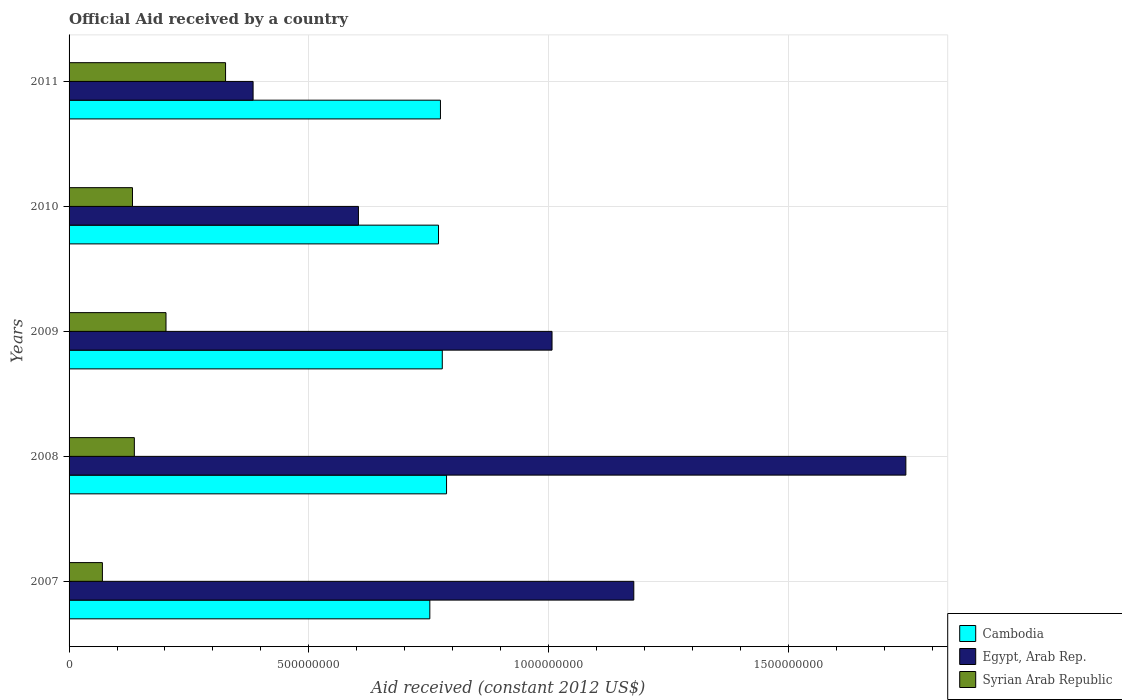How many groups of bars are there?
Ensure brevity in your answer.  5. Are the number of bars on each tick of the Y-axis equal?
Provide a short and direct response. Yes. How many bars are there on the 5th tick from the bottom?
Provide a short and direct response. 3. In how many cases, is the number of bars for a given year not equal to the number of legend labels?
Give a very brief answer. 0. What is the net official aid received in Syrian Arab Republic in 2007?
Your answer should be very brief. 6.95e+07. Across all years, what is the maximum net official aid received in Cambodia?
Provide a succinct answer. 7.87e+08. Across all years, what is the minimum net official aid received in Syrian Arab Republic?
Give a very brief answer. 6.95e+07. In which year was the net official aid received in Syrian Arab Republic minimum?
Your answer should be compact. 2007. What is the total net official aid received in Cambodia in the graph?
Your answer should be compact. 3.86e+09. What is the difference between the net official aid received in Cambodia in 2007 and that in 2009?
Your response must be concise. -2.60e+07. What is the difference between the net official aid received in Syrian Arab Republic in 2009 and the net official aid received in Cambodia in 2011?
Provide a short and direct response. -5.72e+08. What is the average net official aid received in Egypt, Arab Rep. per year?
Ensure brevity in your answer.  9.84e+08. In the year 2009, what is the difference between the net official aid received in Egypt, Arab Rep. and net official aid received in Syrian Arab Republic?
Your answer should be compact. 8.05e+08. In how many years, is the net official aid received in Syrian Arab Republic greater than 900000000 US$?
Make the answer very short. 0. What is the ratio of the net official aid received in Egypt, Arab Rep. in 2008 to that in 2010?
Offer a terse response. 2.89. Is the net official aid received in Cambodia in 2007 less than that in 2009?
Keep it short and to the point. Yes. Is the difference between the net official aid received in Egypt, Arab Rep. in 2008 and 2010 greater than the difference between the net official aid received in Syrian Arab Republic in 2008 and 2010?
Your response must be concise. Yes. What is the difference between the highest and the second highest net official aid received in Syrian Arab Republic?
Ensure brevity in your answer.  1.24e+08. What is the difference between the highest and the lowest net official aid received in Cambodia?
Provide a succinct answer. 3.49e+07. In how many years, is the net official aid received in Egypt, Arab Rep. greater than the average net official aid received in Egypt, Arab Rep. taken over all years?
Your answer should be very brief. 3. What does the 1st bar from the top in 2010 represents?
Offer a terse response. Syrian Arab Republic. What does the 1st bar from the bottom in 2009 represents?
Your answer should be very brief. Cambodia. Is it the case that in every year, the sum of the net official aid received in Cambodia and net official aid received in Egypt, Arab Rep. is greater than the net official aid received in Syrian Arab Republic?
Your response must be concise. Yes. How many years are there in the graph?
Offer a very short reply. 5. What is the difference between two consecutive major ticks on the X-axis?
Your response must be concise. 5.00e+08. Does the graph contain grids?
Ensure brevity in your answer.  Yes. Where does the legend appear in the graph?
Ensure brevity in your answer.  Bottom right. How many legend labels are there?
Your answer should be very brief. 3. What is the title of the graph?
Provide a short and direct response. Official Aid received by a country. Does "Lao PDR" appear as one of the legend labels in the graph?
Offer a terse response. No. What is the label or title of the X-axis?
Make the answer very short. Aid received (constant 2012 US$). What is the Aid received (constant 2012 US$) in Cambodia in 2007?
Give a very brief answer. 7.52e+08. What is the Aid received (constant 2012 US$) of Egypt, Arab Rep. in 2007?
Your answer should be compact. 1.18e+09. What is the Aid received (constant 2012 US$) of Syrian Arab Republic in 2007?
Your answer should be compact. 6.95e+07. What is the Aid received (constant 2012 US$) in Cambodia in 2008?
Ensure brevity in your answer.  7.87e+08. What is the Aid received (constant 2012 US$) of Egypt, Arab Rep. in 2008?
Give a very brief answer. 1.75e+09. What is the Aid received (constant 2012 US$) in Syrian Arab Republic in 2008?
Provide a succinct answer. 1.36e+08. What is the Aid received (constant 2012 US$) of Cambodia in 2009?
Provide a succinct answer. 7.78e+08. What is the Aid received (constant 2012 US$) in Egypt, Arab Rep. in 2009?
Give a very brief answer. 1.01e+09. What is the Aid received (constant 2012 US$) in Syrian Arab Republic in 2009?
Provide a succinct answer. 2.02e+08. What is the Aid received (constant 2012 US$) of Cambodia in 2010?
Give a very brief answer. 7.71e+08. What is the Aid received (constant 2012 US$) of Egypt, Arab Rep. in 2010?
Provide a succinct answer. 6.04e+08. What is the Aid received (constant 2012 US$) of Syrian Arab Republic in 2010?
Provide a short and direct response. 1.32e+08. What is the Aid received (constant 2012 US$) in Cambodia in 2011?
Provide a short and direct response. 7.75e+08. What is the Aid received (constant 2012 US$) of Egypt, Arab Rep. in 2011?
Make the answer very short. 3.84e+08. What is the Aid received (constant 2012 US$) in Syrian Arab Republic in 2011?
Offer a terse response. 3.26e+08. Across all years, what is the maximum Aid received (constant 2012 US$) in Cambodia?
Ensure brevity in your answer.  7.87e+08. Across all years, what is the maximum Aid received (constant 2012 US$) of Egypt, Arab Rep.?
Keep it short and to the point. 1.75e+09. Across all years, what is the maximum Aid received (constant 2012 US$) of Syrian Arab Republic?
Keep it short and to the point. 3.26e+08. Across all years, what is the minimum Aid received (constant 2012 US$) of Cambodia?
Your answer should be very brief. 7.52e+08. Across all years, what is the minimum Aid received (constant 2012 US$) of Egypt, Arab Rep.?
Your answer should be very brief. 3.84e+08. Across all years, what is the minimum Aid received (constant 2012 US$) of Syrian Arab Republic?
Your response must be concise. 6.95e+07. What is the total Aid received (constant 2012 US$) in Cambodia in the graph?
Your answer should be very brief. 3.86e+09. What is the total Aid received (constant 2012 US$) in Egypt, Arab Rep. in the graph?
Keep it short and to the point. 4.92e+09. What is the total Aid received (constant 2012 US$) in Syrian Arab Republic in the graph?
Ensure brevity in your answer.  8.66e+08. What is the difference between the Aid received (constant 2012 US$) in Cambodia in 2007 and that in 2008?
Make the answer very short. -3.49e+07. What is the difference between the Aid received (constant 2012 US$) of Egypt, Arab Rep. in 2007 and that in 2008?
Ensure brevity in your answer.  -5.67e+08. What is the difference between the Aid received (constant 2012 US$) in Syrian Arab Republic in 2007 and that in 2008?
Make the answer very short. -6.66e+07. What is the difference between the Aid received (constant 2012 US$) in Cambodia in 2007 and that in 2009?
Keep it short and to the point. -2.60e+07. What is the difference between the Aid received (constant 2012 US$) in Egypt, Arab Rep. in 2007 and that in 2009?
Provide a short and direct response. 1.71e+08. What is the difference between the Aid received (constant 2012 US$) of Syrian Arab Republic in 2007 and that in 2009?
Provide a short and direct response. -1.33e+08. What is the difference between the Aid received (constant 2012 US$) in Cambodia in 2007 and that in 2010?
Your answer should be compact. -1.81e+07. What is the difference between the Aid received (constant 2012 US$) of Egypt, Arab Rep. in 2007 and that in 2010?
Your answer should be compact. 5.74e+08. What is the difference between the Aid received (constant 2012 US$) of Syrian Arab Republic in 2007 and that in 2010?
Your answer should be compact. -6.27e+07. What is the difference between the Aid received (constant 2012 US$) of Cambodia in 2007 and that in 2011?
Give a very brief answer. -2.22e+07. What is the difference between the Aid received (constant 2012 US$) of Egypt, Arab Rep. in 2007 and that in 2011?
Offer a terse response. 7.94e+08. What is the difference between the Aid received (constant 2012 US$) in Syrian Arab Republic in 2007 and that in 2011?
Make the answer very short. -2.57e+08. What is the difference between the Aid received (constant 2012 US$) in Cambodia in 2008 and that in 2009?
Keep it short and to the point. 8.88e+06. What is the difference between the Aid received (constant 2012 US$) in Egypt, Arab Rep. in 2008 and that in 2009?
Provide a succinct answer. 7.38e+08. What is the difference between the Aid received (constant 2012 US$) in Syrian Arab Republic in 2008 and that in 2009?
Your response must be concise. -6.60e+07. What is the difference between the Aid received (constant 2012 US$) in Cambodia in 2008 and that in 2010?
Your answer should be compact. 1.68e+07. What is the difference between the Aid received (constant 2012 US$) of Egypt, Arab Rep. in 2008 and that in 2010?
Offer a terse response. 1.14e+09. What is the difference between the Aid received (constant 2012 US$) in Syrian Arab Republic in 2008 and that in 2010?
Offer a terse response. 3.90e+06. What is the difference between the Aid received (constant 2012 US$) of Cambodia in 2008 and that in 2011?
Your answer should be very brief. 1.27e+07. What is the difference between the Aid received (constant 2012 US$) in Egypt, Arab Rep. in 2008 and that in 2011?
Make the answer very short. 1.36e+09. What is the difference between the Aid received (constant 2012 US$) in Syrian Arab Republic in 2008 and that in 2011?
Offer a terse response. -1.90e+08. What is the difference between the Aid received (constant 2012 US$) in Cambodia in 2009 and that in 2010?
Your answer should be compact. 7.87e+06. What is the difference between the Aid received (constant 2012 US$) of Egypt, Arab Rep. in 2009 and that in 2010?
Keep it short and to the point. 4.04e+08. What is the difference between the Aid received (constant 2012 US$) of Syrian Arab Republic in 2009 and that in 2010?
Provide a short and direct response. 6.99e+07. What is the difference between the Aid received (constant 2012 US$) of Cambodia in 2009 and that in 2011?
Ensure brevity in your answer.  3.82e+06. What is the difference between the Aid received (constant 2012 US$) of Egypt, Arab Rep. in 2009 and that in 2011?
Offer a terse response. 6.24e+08. What is the difference between the Aid received (constant 2012 US$) in Syrian Arab Republic in 2009 and that in 2011?
Make the answer very short. -1.24e+08. What is the difference between the Aid received (constant 2012 US$) of Cambodia in 2010 and that in 2011?
Ensure brevity in your answer.  -4.05e+06. What is the difference between the Aid received (constant 2012 US$) of Egypt, Arab Rep. in 2010 and that in 2011?
Offer a very short reply. 2.20e+08. What is the difference between the Aid received (constant 2012 US$) in Syrian Arab Republic in 2010 and that in 2011?
Your response must be concise. -1.94e+08. What is the difference between the Aid received (constant 2012 US$) of Cambodia in 2007 and the Aid received (constant 2012 US$) of Egypt, Arab Rep. in 2008?
Your answer should be very brief. -9.93e+08. What is the difference between the Aid received (constant 2012 US$) in Cambodia in 2007 and the Aid received (constant 2012 US$) in Syrian Arab Republic in 2008?
Provide a short and direct response. 6.16e+08. What is the difference between the Aid received (constant 2012 US$) of Egypt, Arab Rep. in 2007 and the Aid received (constant 2012 US$) of Syrian Arab Republic in 2008?
Offer a terse response. 1.04e+09. What is the difference between the Aid received (constant 2012 US$) in Cambodia in 2007 and the Aid received (constant 2012 US$) in Egypt, Arab Rep. in 2009?
Provide a short and direct response. -2.55e+08. What is the difference between the Aid received (constant 2012 US$) in Cambodia in 2007 and the Aid received (constant 2012 US$) in Syrian Arab Republic in 2009?
Make the answer very short. 5.50e+08. What is the difference between the Aid received (constant 2012 US$) of Egypt, Arab Rep. in 2007 and the Aid received (constant 2012 US$) of Syrian Arab Republic in 2009?
Provide a short and direct response. 9.76e+08. What is the difference between the Aid received (constant 2012 US$) in Cambodia in 2007 and the Aid received (constant 2012 US$) in Egypt, Arab Rep. in 2010?
Your answer should be compact. 1.49e+08. What is the difference between the Aid received (constant 2012 US$) in Cambodia in 2007 and the Aid received (constant 2012 US$) in Syrian Arab Republic in 2010?
Offer a very short reply. 6.20e+08. What is the difference between the Aid received (constant 2012 US$) in Egypt, Arab Rep. in 2007 and the Aid received (constant 2012 US$) in Syrian Arab Republic in 2010?
Your answer should be compact. 1.05e+09. What is the difference between the Aid received (constant 2012 US$) in Cambodia in 2007 and the Aid received (constant 2012 US$) in Egypt, Arab Rep. in 2011?
Provide a succinct answer. 3.69e+08. What is the difference between the Aid received (constant 2012 US$) in Cambodia in 2007 and the Aid received (constant 2012 US$) in Syrian Arab Republic in 2011?
Offer a terse response. 4.26e+08. What is the difference between the Aid received (constant 2012 US$) of Egypt, Arab Rep. in 2007 and the Aid received (constant 2012 US$) of Syrian Arab Republic in 2011?
Provide a succinct answer. 8.51e+08. What is the difference between the Aid received (constant 2012 US$) in Cambodia in 2008 and the Aid received (constant 2012 US$) in Egypt, Arab Rep. in 2009?
Provide a succinct answer. -2.20e+08. What is the difference between the Aid received (constant 2012 US$) in Cambodia in 2008 and the Aid received (constant 2012 US$) in Syrian Arab Republic in 2009?
Offer a terse response. 5.85e+08. What is the difference between the Aid received (constant 2012 US$) of Egypt, Arab Rep. in 2008 and the Aid received (constant 2012 US$) of Syrian Arab Republic in 2009?
Your answer should be compact. 1.54e+09. What is the difference between the Aid received (constant 2012 US$) of Cambodia in 2008 and the Aid received (constant 2012 US$) of Egypt, Arab Rep. in 2010?
Provide a succinct answer. 1.84e+08. What is the difference between the Aid received (constant 2012 US$) in Cambodia in 2008 and the Aid received (constant 2012 US$) in Syrian Arab Republic in 2010?
Your answer should be very brief. 6.55e+08. What is the difference between the Aid received (constant 2012 US$) in Egypt, Arab Rep. in 2008 and the Aid received (constant 2012 US$) in Syrian Arab Republic in 2010?
Provide a succinct answer. 1.61e+09. What is the difference between the Aid received (constant 2012 US$) in Cambodia in 2008 and the Aid received (constant 2012 US$) in Egypt, Arab Rep. in 2011?
Offer a very short reply. 4.04e+08. What is the difference between the Aid received (constant 2012 US$) in Cambodia in 2008 and the Aid received (constant 2012 US$) in Syrian Arab Republic in 2011?
Provide a short and direct response. 4.61e+08. What is the difference between the Aid received (constant 2012 US$) in Egypt, Arab Rep. in 2008 and the Aid received (constant 2012 US$) in Syrian Arab Republic in 2011?
Give a very brief answer. 1.42e+09. What is the difference between the Aid received (constant 2012 US$) in Cambodia in 2009 and the Aid received (constant 2012 US$) in Egypt, Arab Rep. in 2010?
Keep it short and to the point. 1.75e+08. What is the difference between the Aid received (constant 2012 US$) of Cambodia in 2009 and the Aid received (constant 2012 US$) of Syrian Arab Republic in 2010?
Give a very brief answer. 6.46e+08. What is the difference between the Aid received (constant 2012 US$) of Egypt, Arab Rep. in 2009 and the Aid received (constant 2012 US$) of Syrian Arab Republic in 2010?
Ensure brevity in your answer.  8.75e+08. What is the difference between the Aid received (constant 2012 US$) of Cambodia in 2009 and the Aid received (constant 2012 US$) of Egypt, Arab Rep. in 2011?
Your response must be concise. 3.95e+08. What is the difference between the Aid received (constant 2012 US$) in Cambodia in 2009 and the Aid received (constant 2012 US$) in Syrian Arab Republic in 2011?
Your response must be concise. 4.52e+08. What is the difference between the Aid received (constant 2012 US$) in Egypt, Arab Rep. in 2009 and the Aid received (constant 2012 US$) in Syrian Arab Republic in 2011?
Give a very brief answer. 6.81e+08. What is the difference between the Aid received (constant 2012 US$) of Cambodia in 2010 and the Aid received (constant 2012 US$) of Egypt, Arab Rep. in 2011?
Give a very brief answer. 3.87e+08. What is the difference between the Aid received (constant 2012 US$) in Cambodia in 2010 and the Aid received (constant 2012 US$) in Syrian Arab Republic in 2011?
Keep it short and to the point. 4.44e+08. What is the difference between the Aid received (constant 2012 US$) of Egypt, Arab Rep. in 2010 and the Aid received (constant 2012 US$) of Syrian Arab Republic in 2011?
Your answer should be compact. 2.77e+08. What is the average Aid received (constant 2012 US$) of Cambodia per year?
Your answer should be compact. 7.73e+08. What is the average Aid received (constant 2012 US$) of Egypt, Arab Rep. per year?
Your answer should be compact. 9.84e+08. What is the average Aid received (constant 2012 US$) in Syrian Arab Republic per year?
Provide a succinct answer. 1.73e+08. In the year 2007, what is the difference between the Aid received (constant 2012 US$) of Cambodia and Aid received (constant 2012 US$) of Egypt, Arab Rep.?
Your answer should be very brief. -4.25e+08. In the year 2007, what is the difference between the Aid received (constant 2012 US$) of Cambodia and Aid received (constant 2012 US$) of Syrian Arab Republic?
Provide a short and direct response. 6.83e+08. In the year 2007, what is the difference between the Aid received (constant 2012 US$) of Egypt, Arab Rep. and Aid received (constant 2012 US$) of Syrian Arab Republic?
Ensure brevity in your answer.  1.11e+09. In the year 2008, what is the difference between the Aid received (constant 2012 US$) of Cambodia and Aid received (constant 2012 US$) of Egypt, Arab Rep.?
Offer a very short reply. -9.58e+08. In the year 2008, what is the difference between the Aid received (constant 2012 US$) in Cambodia and Aid received (constant 2012 US$) in Syrian Arab Republic?
Offer a very short reply. 6.51e+08. In the year 2008, what is the difference between the Aid received (constant 2012 US$) in Egypt, Arab Rep. and Aid received (constant 2012 US$) in Syrian Arab Republic?
Offer a terse response. 1.61e+09. In the year 2009, what is the difference between the Aid received (constant 2012 US$) of Cambodia and Aid received (constant 2012 US$) of Egypt, Arab Rep.?
Your answer should be very brief. -2.29e+08. In the year 2009, what is the difference between the Aid received (constant 2012 US$) in Cambodia and Aid received (constant 2012 US$) in Syrian Arab Republic?
Make the answer very short. 5.76e+08. In the year 2009, what is the difference between the Aid received (constant 2012 US$) in Egypt, Arab Rep. and Aid received (constant 2012 US$) in Syrian Arab Republic?
Make the answer very short. 8.05e+08. In the year 2010, what is the difference between the Aid received (constant 2012 US$) of Cambodia and Aid received (constant 2012 US$) of Egypt, Arab Rep.?
Ensure brevity in your answer.  1.67e+08. In the year 2010, what is the difference between the Aid received (constant 2012 US$) in Cambodia and Aid received (constant 2012 US$) in Syrian Arab Republic?
Your answer should be very brief. 6.38e+08. In the year 2010, what is the difference between the Aid received (constant 2012 US$) of Egypt, Arab Rep. and Aid received (constant 2012 US$) of Syrian Arab Republic?
Provide a succinct answer. 4.71e+08. In the year 2011, what is the difference between the Aid received (constant 2012 US$) in Cambodia and Aid received (constant 2012 US$) in Egypt, Arab Rep.?
Keep it short and to the point. 3.91e+08. In the year 2011, what is the difference between the Aid received (constant 2012 US$) in Cambodia and Aid received (constant 2012 US$) in Syrian Arab Republic?
Keep it short and to the point. 4.48e+08. In the year 2011, what is the difference between the Aid received (constant 2012 US$) of Egypt, Arab Rep. and Aid received (constant 2012 US$) of Syrian Arab Republic?
Provide a short and direct response. 5.74e+07. What is the ratio of the Aid received (constant 2012 US$) in Cambodia in 2007 to that in 2008?
Make the answer very short. 0.96. What is the ratio of the Aid received (constant 2012 US$) in Egypt, Arab Rep. in 2007 to that in 2008?
Keep it short and to the point. 0.67. What is the ratio of the Aid received (constant 2012 US$) in Syrian Arab Republic in 2007 to that in 2008?
Give a very brief answer. 0.51. What is the ratio of the Aid received (constant 2012 US$) in Cambodia in 2007 to that in 2009?
Provide a short and direct response. 0.97. What is the ratio of the Aid received (constant 2012 US$) in Egypt, Arab Rep. in 2007 to that in 2009?
Provide a succinct answer. 1.17. What is the ratio of the Aid received (constant 2012 US$) in Syrian Arab Republic in 2007 to that in 2009?
Ensure brevity in your answer.  0.34. What is the ratio of the Aid received (constant 2012 US$) in Cambodia in 2007 to that in 2010?
Provide a succinct answer. 0.98. What is the ratio of the Aid received (constant 2012 US$) in Egypt, Arab Rep. in 2007 to that in 2010?
Offer a terse response. 1.95. What is the ratio of the Aid received (constant 2012 US$) of Syrian Arab Republic in 2007 to that in 2010?
Your answer should be very brief. 0.53. What is the ratio of the Aid received (constant 2012 US$) in Cambodia in 2007 to that in 2011?
Your response must be concise. 0.97. What is the ratio of the Aid received (constant 2012 US$) of Egypt, Arab Rep. in 2007 to that in 2011?
Offer a terse response. 3.07. What is the ratio of the Aid received (constant 2012 US$) of Syrian Arab Republic in 2007 to that in 2011?
Keep it short and to the point. 0.21. What is the ratio of the Aid received (constant 2012 US$) of Cambodia in 2008 to that in 2009?
Offer a terse response. 1.01. What is the ratio of the Aid received (constant 2012 US$) in Egypt, Arab Rep. in 2008 to that in 2009?
Ensure brevity in your answer.  1.73. What is the ratio of the Aid received (constant 2012 US$) in Syrian Arab Republic in 2008 to that in 2009?
Ensure brevity in your answer.  0.67. What is the ratio of the Aid received (constant 2012 US$) of Cambodia in 2008 to that in 2010?
Your answer should be very brief. 1.02. What is the ratio of the Aid received (constant 2012 US$) in Egypt, Arab Rep. in 2008 to that in 2010?
Ensure brevity in your answer.  2.89. What is the ratio of the Aid received (constant 2012 US$) of Syrian Arab Republic in 2008 to that in 2010?
Your answer should be very brief. 1.03. What is the ratio of the Aid received (constant 2012 US$) in Cambodia in 2008 to that in 2011?
Your answer should be compact. 1.02. What is the ratio of the Aid received (constant 2012 US$) of Egypt, Arab Rep. in 2008 to that in 2011?
Provide a short and direct response. 4.55. What is the ratio of the Aid received (constant 2012 US$) of Syrian Arab Republic in 2008 to that in 2011?
Provide a succinct answer. 0.42. What is the ratio of the Aid received (constant 2012 US$) in Cambodia in 2009 to that in 2010?
Keep it short and to the point. 1.01. What is the ratio of the Aid received (constant 2012 US$) in Egypt, Arab Rep. in 2009 to that in 2010?
Provide a succinct answer. 1.67. What is the ratio of the Aid received (constant 2012 US$) of Syrian Arab Republic in 2009 to that in 2010?
Your answer should be compact. 1.53. What is the ratio of the Aid received (constant 2012 US$) in Cambodia in 2009 to that in 2011?
Ensure brevity in your answer.  1. What is the ratio of the Aid received (constant 2012 US$) of Egypt, Arab Rep. in 2009 to that in 2011?
Ensure brevity in your answer.  2.62. What is the ratio of the Aid received (constant 2012 US$) of Syrian Arab Republic in 2009 to that in 2011?
Keep it short and to the point. 0.62. What is the ratio of the Aid received (constant 2012 US$) in Cambodia in 2010 to that in 2011?
Offer a terse response. 0.99. What is the ratio of the Aid received (constant 2012 US$) of Egypt, Arab Rep. in 2010 to that in 2011?
Your response must be concise. 1.57. What is the ratio of the Aid received (constant 2012 US$) of Syrian Arab Republic in 2010 to that in 2011?
Give a very brief answer. 0.41. What is the difference between the highest and the second highest Aid received (constant 2012 US$) in Cambodia?
Keep it short and to the point. 8.88e+06. What is the difference between the highest and the second highest Aid received (constant 2012 US$) of Egypt, Arab Rep.?
Offer a very short reply. 5.67e+08. What is the difference between the highest and the second highest Aid received (constant 2012 US$) in Syrian Arab Republic?
Make the answer very short. 1.24e+08. What is the difference between the highest and the lowest Aid received (constant 2012 US$) of Cambodia?
Your response must be concise. 3.49e+07. What is the difference between the highest and the lowest Aid received (constant 2012 US$) of Egypt, Arab Rep.?
Provide a succinct answer. 1.36e+09. What is the difference between the highest and the lowest Aid received (constant 2012 US$) in Syrian Arab Republic?
Provide a short and direct response. 2.57e+08. 